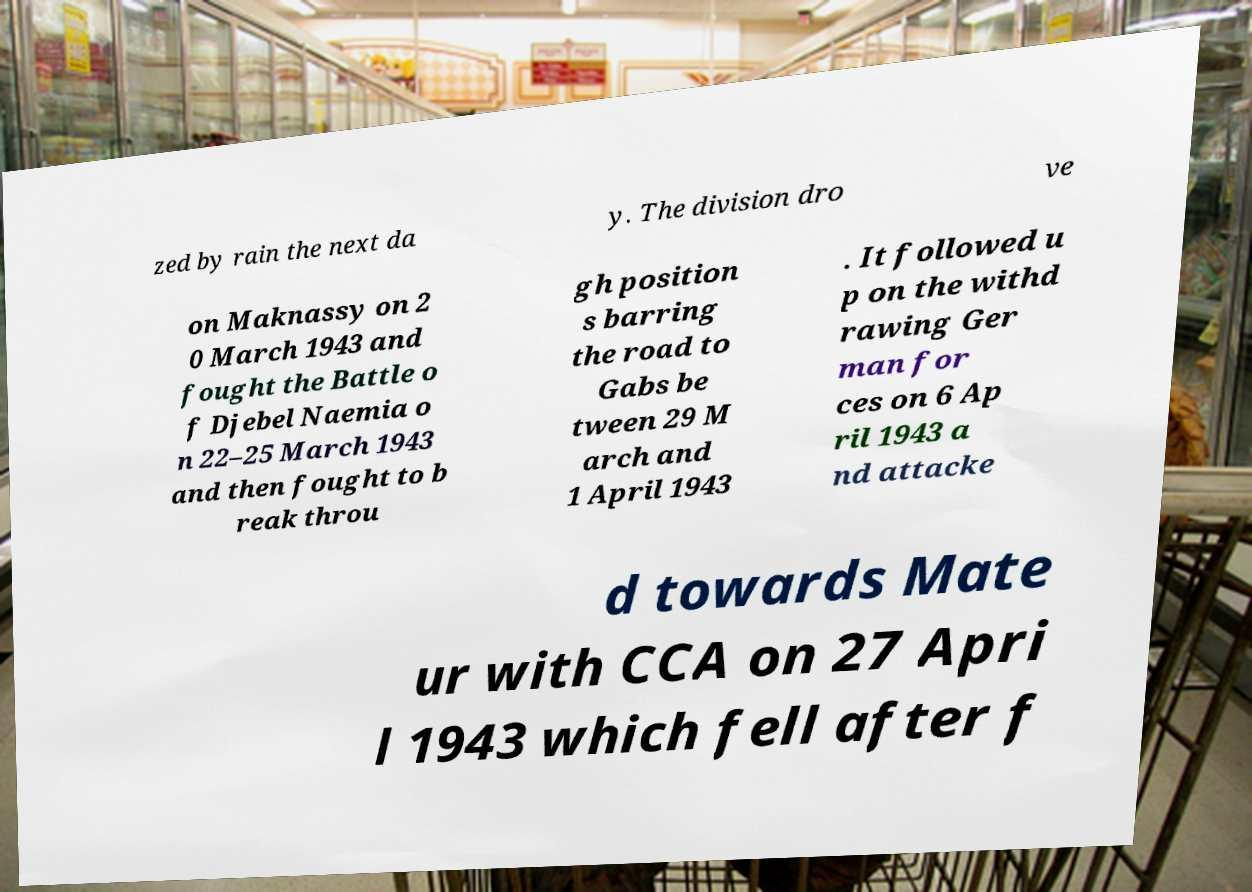For documentation purposes, I need the text within this image transcribed. Could you provide that? zed by rain the next da y. The division dro ve on Maknassy on 2 0 March 1943 and fought the Battle o f Djebel Naemia o n 22–25 March 1943 and then fought to b reak throu gh position s barring the road to Gabs be tween 29 M arch and 1 April 1943 . It followed u p on the withd rawing Ger man for ces on 6 Ap ril 1943 a nd attacke d towards Mate ur with CCA on 27 Apri l 1943 which fell after f 